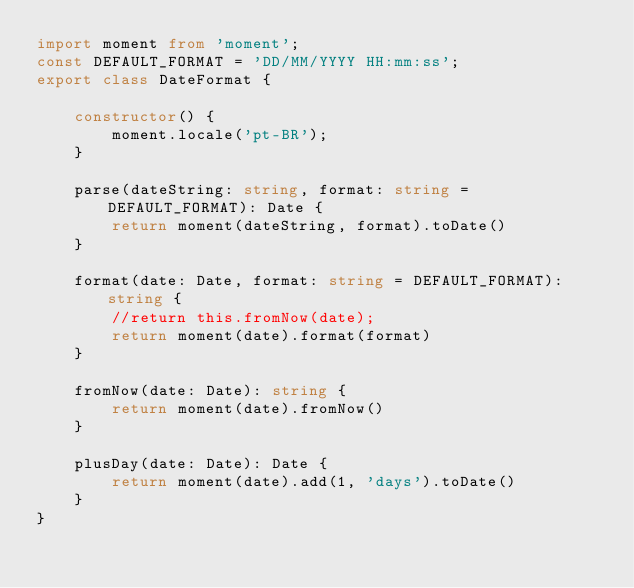<code> <loc_0><loc_0><loc_500><loc_500><_TypeScript_>import moment from 'moment';
const DEFAULT_FORMAT = 'DD/MM/YYYY HH:mm:ss';
export class DateFormat {

    constructor() {
        moment.locale('pt-BR');
    }

    parse(dateString: string, format: string = DEFAULT_FORMAT): Date {
        return moment(dateString, format).toDate()
    }

    format(date: Date, format: string = DEFAULT_FORMAT): string {
        //return this.fromNow(date);
        return moment(date).format(format)
    }

    fromNow(date: Date): string {
        return moment(date).fromNow()
    }

    plusDay(date: Date): Date {
        return moment(date).add(1, 'days').toDate()
    }
}</code> 